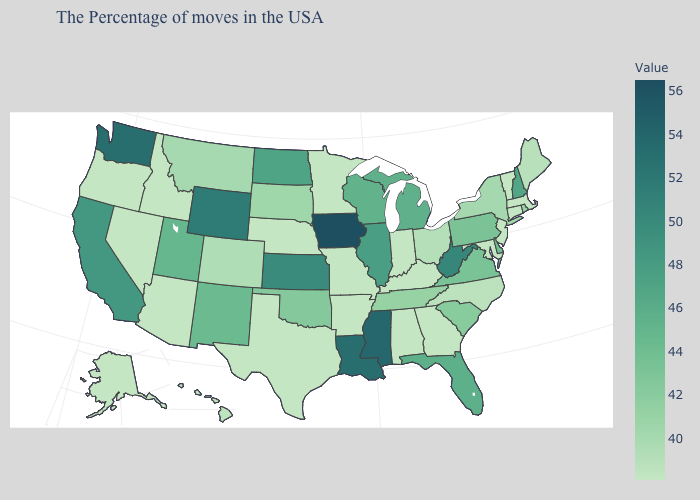Does the map have missing data?
Quick response, please. No. Which states have the highest value in the USA?
Be succinct. Iowa. Which states have the highest value in the USA?
Answer briefly. Iowa. Does Louisiana have a higher value than Iowa?
Answer briefly. No. 